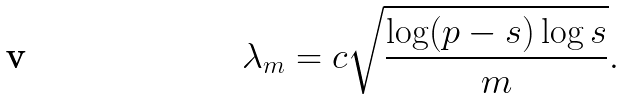<formula> <loc_0><loc_0><loc_500><loc_500>\lambda _ { m } = c \sqrt { \frac { \log ( p - s ) \log s } { m } } .</formula> 